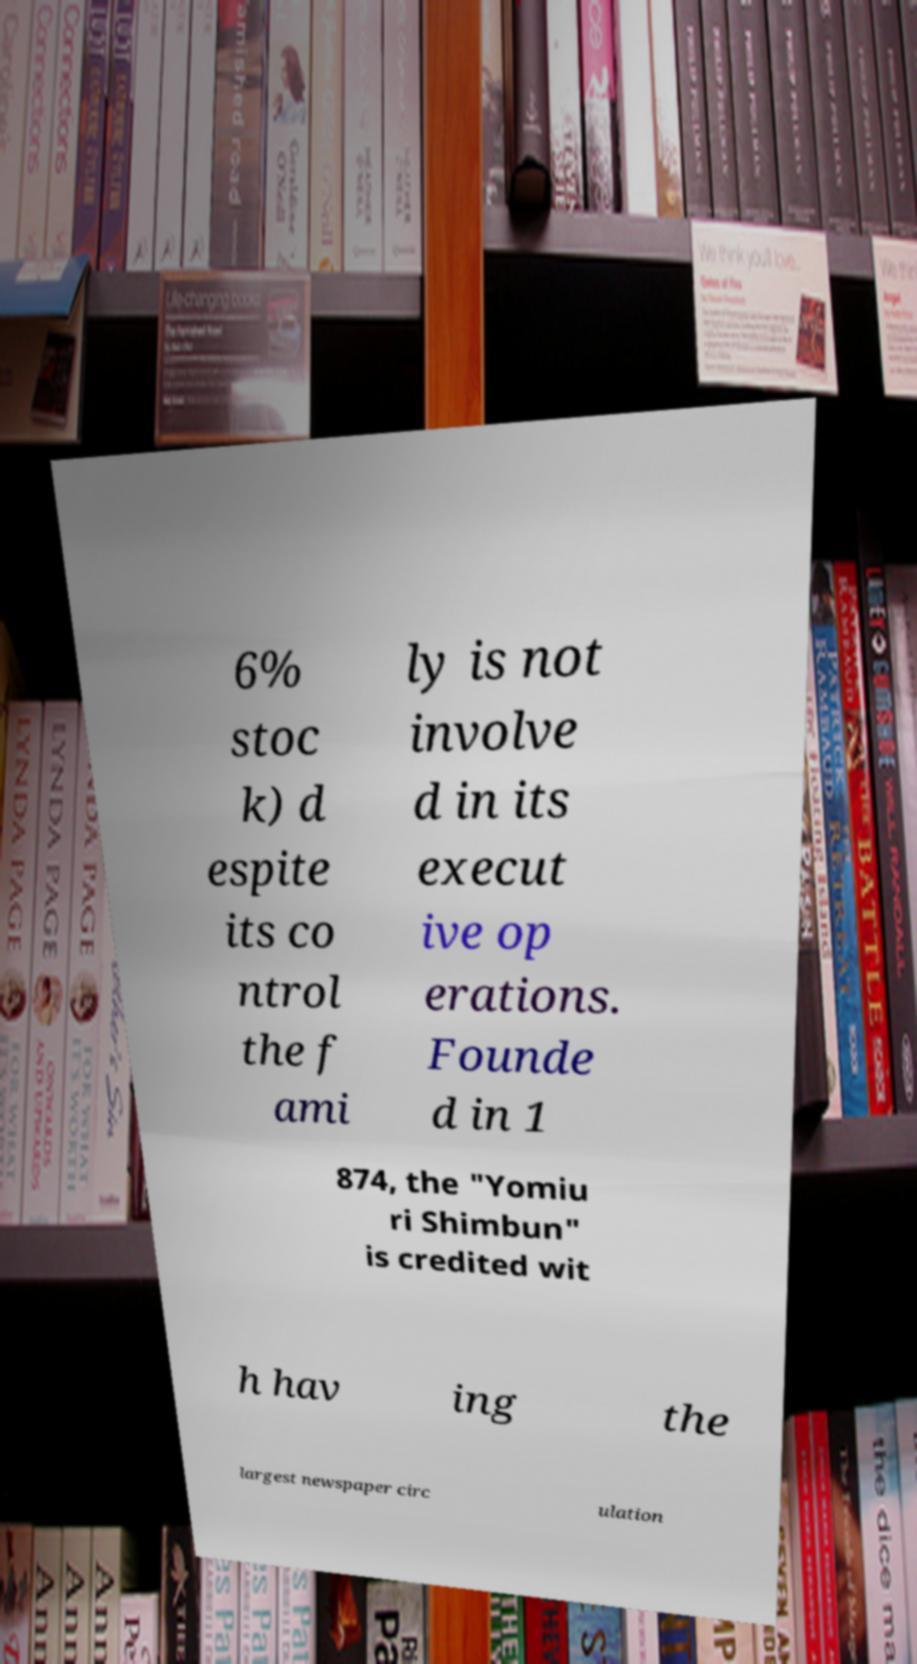What messages or text are displayed in this image? I need them in a readable, typed format. 6% stoc k) d espite its co ntrol the f ami ly is not involve d in its execut ive op erations. Founde d in 1 874, the "Yomiu ri Shimbun" is credited wit h hav ing the largest newspaper circ ulation 